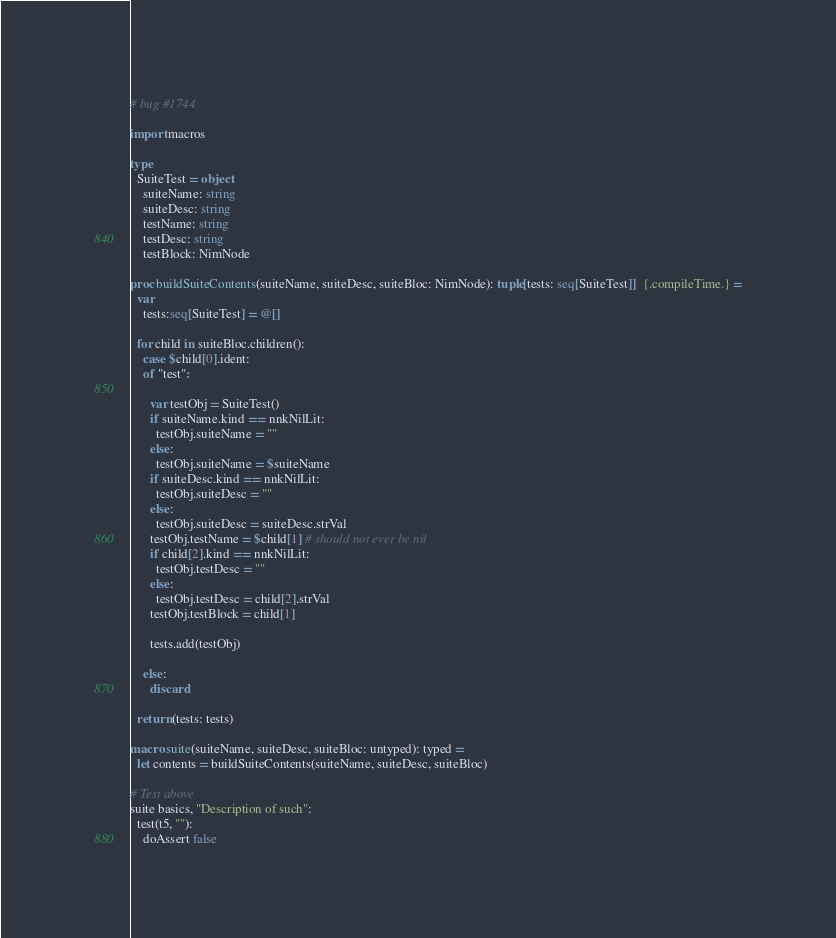<code> <loc_0><loc_0><loc_500><loc_500><_Nim_># bug #1744

import macros

type
  SuiteTest = object
    suiteName: string
    suiteDesc: string
    testName: string
    testDesc: string
    testBlock: NimNode

proc buildSuiteContents(suiteName, suiteDesc, suiteBloc: NimNode): tuple[tests: seq[SuiteTest]]  {.compileTime.} =
  var
    tests:seq[SuiteTest] = @[]

  for child in suiteBloc.children():
    case $child[0].ident:
    of "test":

      var testObj = SuiteTest()
      if suiteName.kind == nnkNilLit:
        testObj.suiteName = ""
      else:
        testObj.suiteName = $suiteName
      if suiteDesc.kind == nnkNilLit:
        testObj.suiteDesc = ""
      else:
        testObj.suiteDesc = suiteDesc.strVal
      testObj.testName = $child[1] # should not ever be nil
      if child[2].kind == nnkNilLit:
        testObj.testDesc = ""
      else:
        testObj.testDesc = child[2].strVal
      testObj.testBlock = child[1]

      tests.add(testObj)

    else:
      discard

  return (tests: tests)

macro suite(suiteName, suiteDesc, suiteBloc: untyped): typed =
  let contents = buildSuiteContents(suiteName, suiteDesc, suiteBloc)

# Test above
suite basics, "Description of such":
  test(t5, ""):
    doAssert false
</code> 